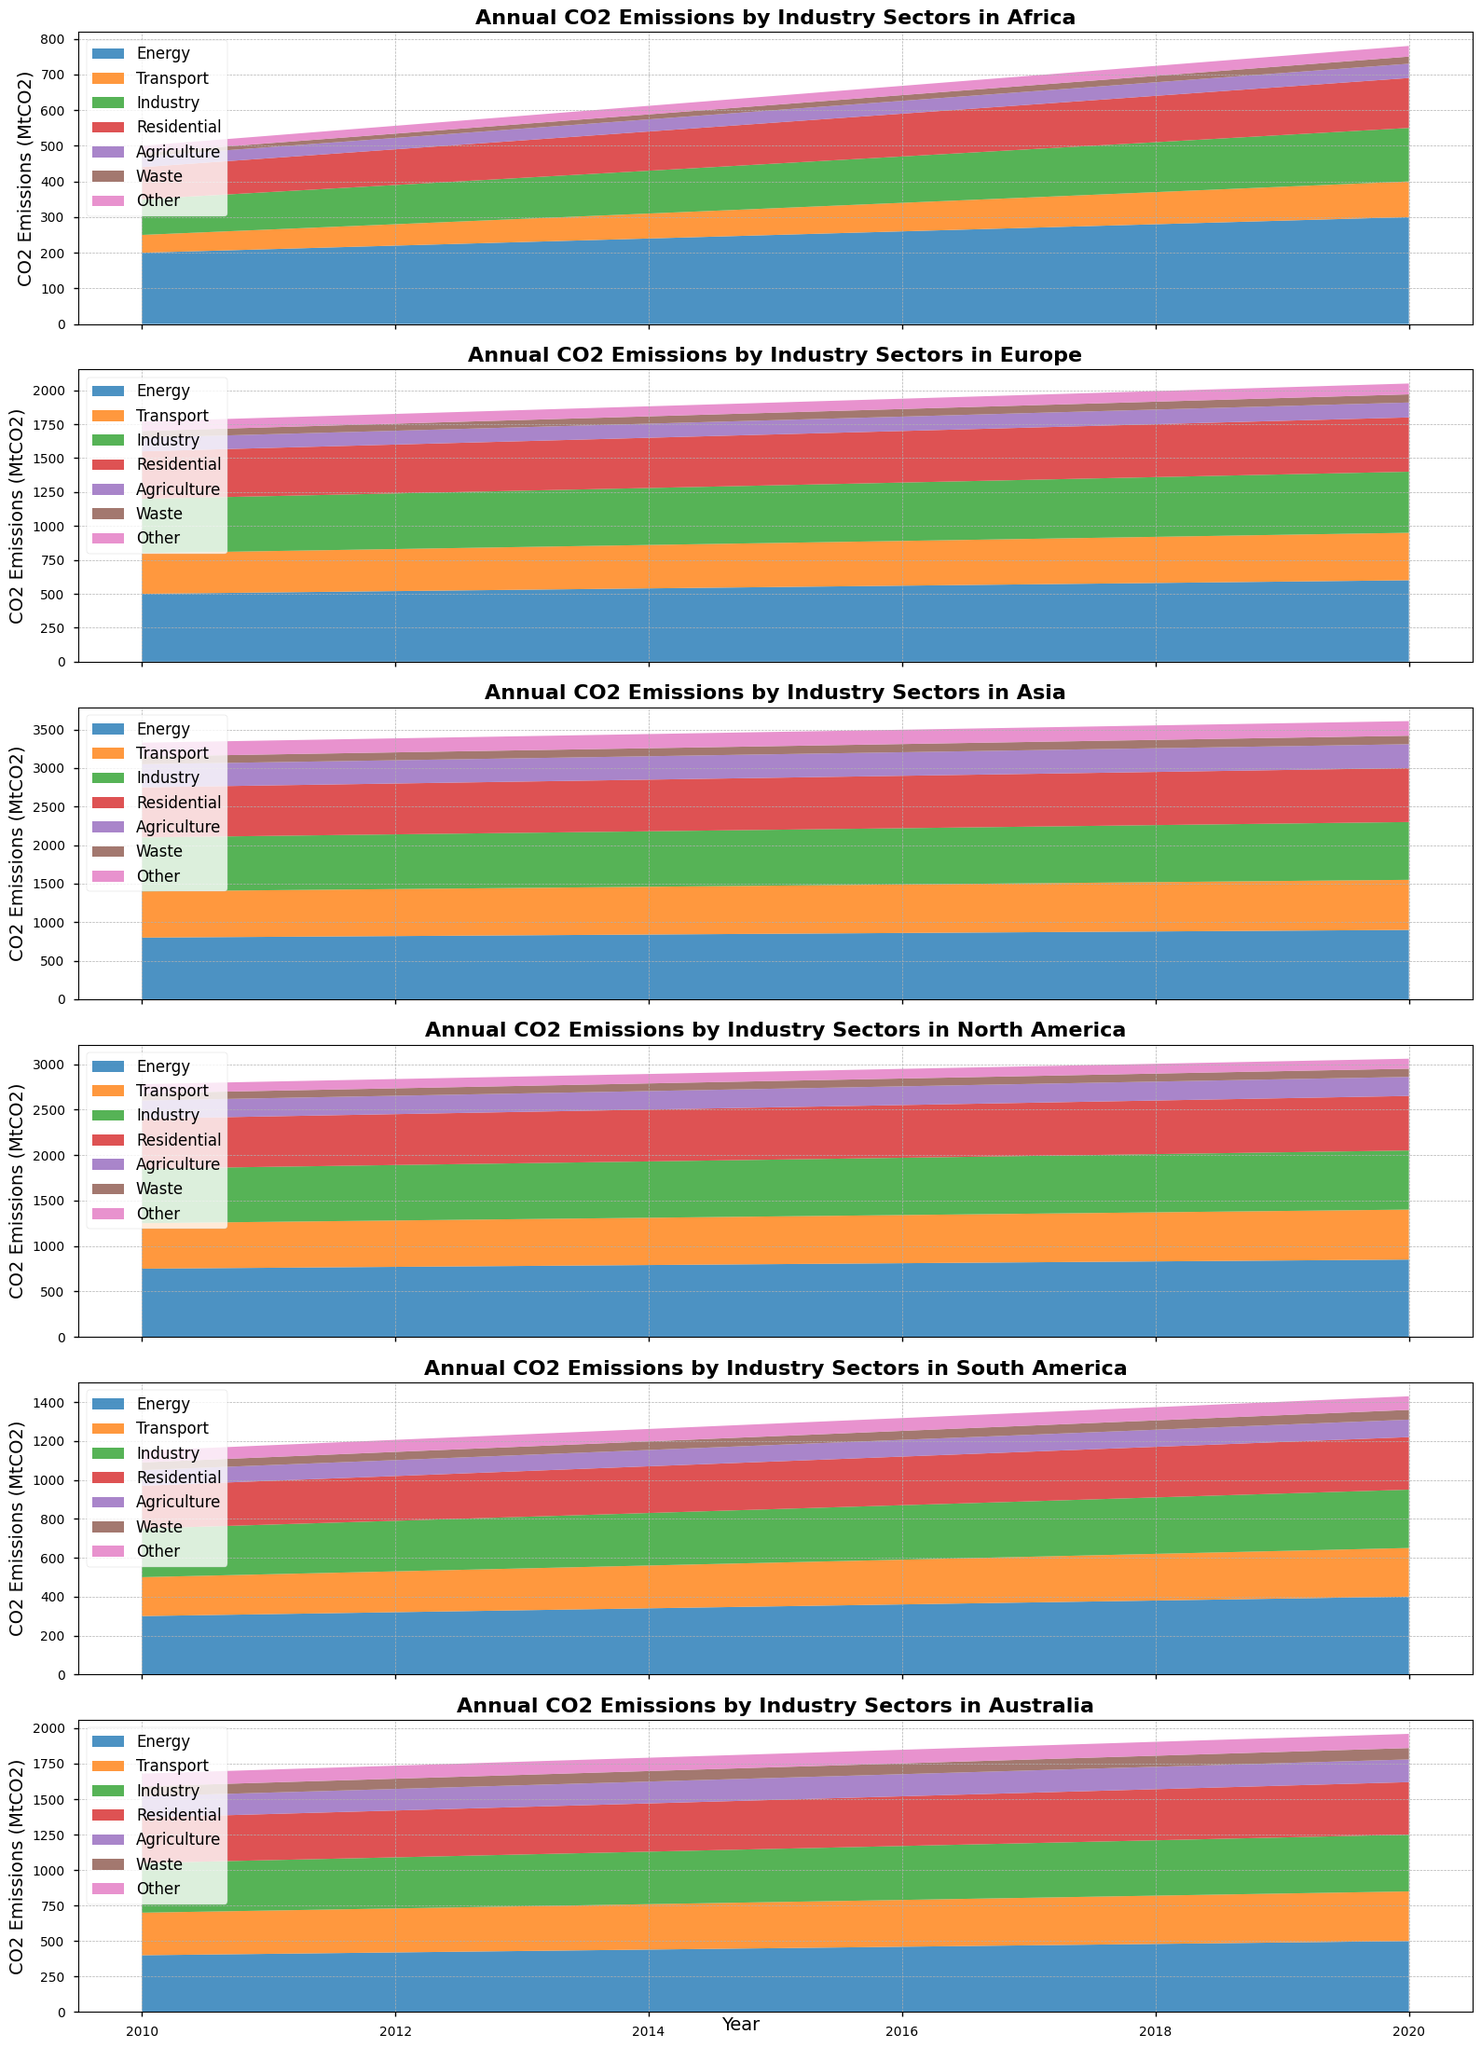Which continent had the highest CO2 emissions from the energy sector in 2020? Look at the energy sector's segment for each continent in 2020. Asia has the highest segment in terms of height.
Answer: Asia Which two sectors had the closest CO2 emissions in Africa in 2015? Compare the heights of the segments for each sector in Africa for 2015. The residential and industry sectors appear to be closest in height.
Answer: Residential, Industry How did Europe's CO2 emissions from the transport sector change from 2011 to 2019? Look at the height of the transport sector’s segment over the years 2011 to 2019 in Europe. It steadily increased from 305 in 2011 to 345 in 2019.
Answer: Increased What was the total CO2 emission from all sectors in South America in 2010? Sum up the heights of all sectors in South America for 2010: 300 + 200 + 250 + 220 + 80 + 40 + 60 = 1150 MtCO2.
Answer: 1150 MtCO2 Which continent experienced the largest increase in CO2 emissions in the energy sector from 2010 to 2020? Compare the difference in heights of the energy sector’s segment from 2010 to 2020 for each continent. Asia's increase from 800 to 900 MtCO2 is the largest.
Answer: Asia How did the CO2 emissions from the waste sector in North America change from 2010 to 2020? Look at the waste sector’s segment for North America from 2010 to 2020. The height changed from 80 to 90 MtCO2, showing a slight increase.
Answer: Increased Which sector had the lowest CO2 emissions in Australia in 2014? Identify the segment with the shortest height in 2014 for Australia. Waste appears to be the lowest.
Answer: Waste In 2017, which sector in South America had higher CO2 emissions: energy or industry? Compare the heights of the energy and industry sectors in South America in 2017. The energy segment is higher than the industry segment.
Answer: Energy What was the change in total CO2 emissions in Europe from 2015 to 2020? Sum the heights of all sectors in Europe for 2015 and 2020, then find the difference: (550+325+425+375+105+55+75) = 1910 and (600+350+450+400+110+60+80) = 2050. The change is 2050 - 1910 = 140.
Answer: 140 MtCO2 Which sector had a more significant increase in CO2 emissions in Africa from 2010 to 2020: transport or energy? Compare the height changes of the transport and energy sectors in Africa from 2010 to 2020: transport increased from 50 to 100, and energy increased from 200 to 300. The energy sector had a more significant increase.
Answer: Energy 